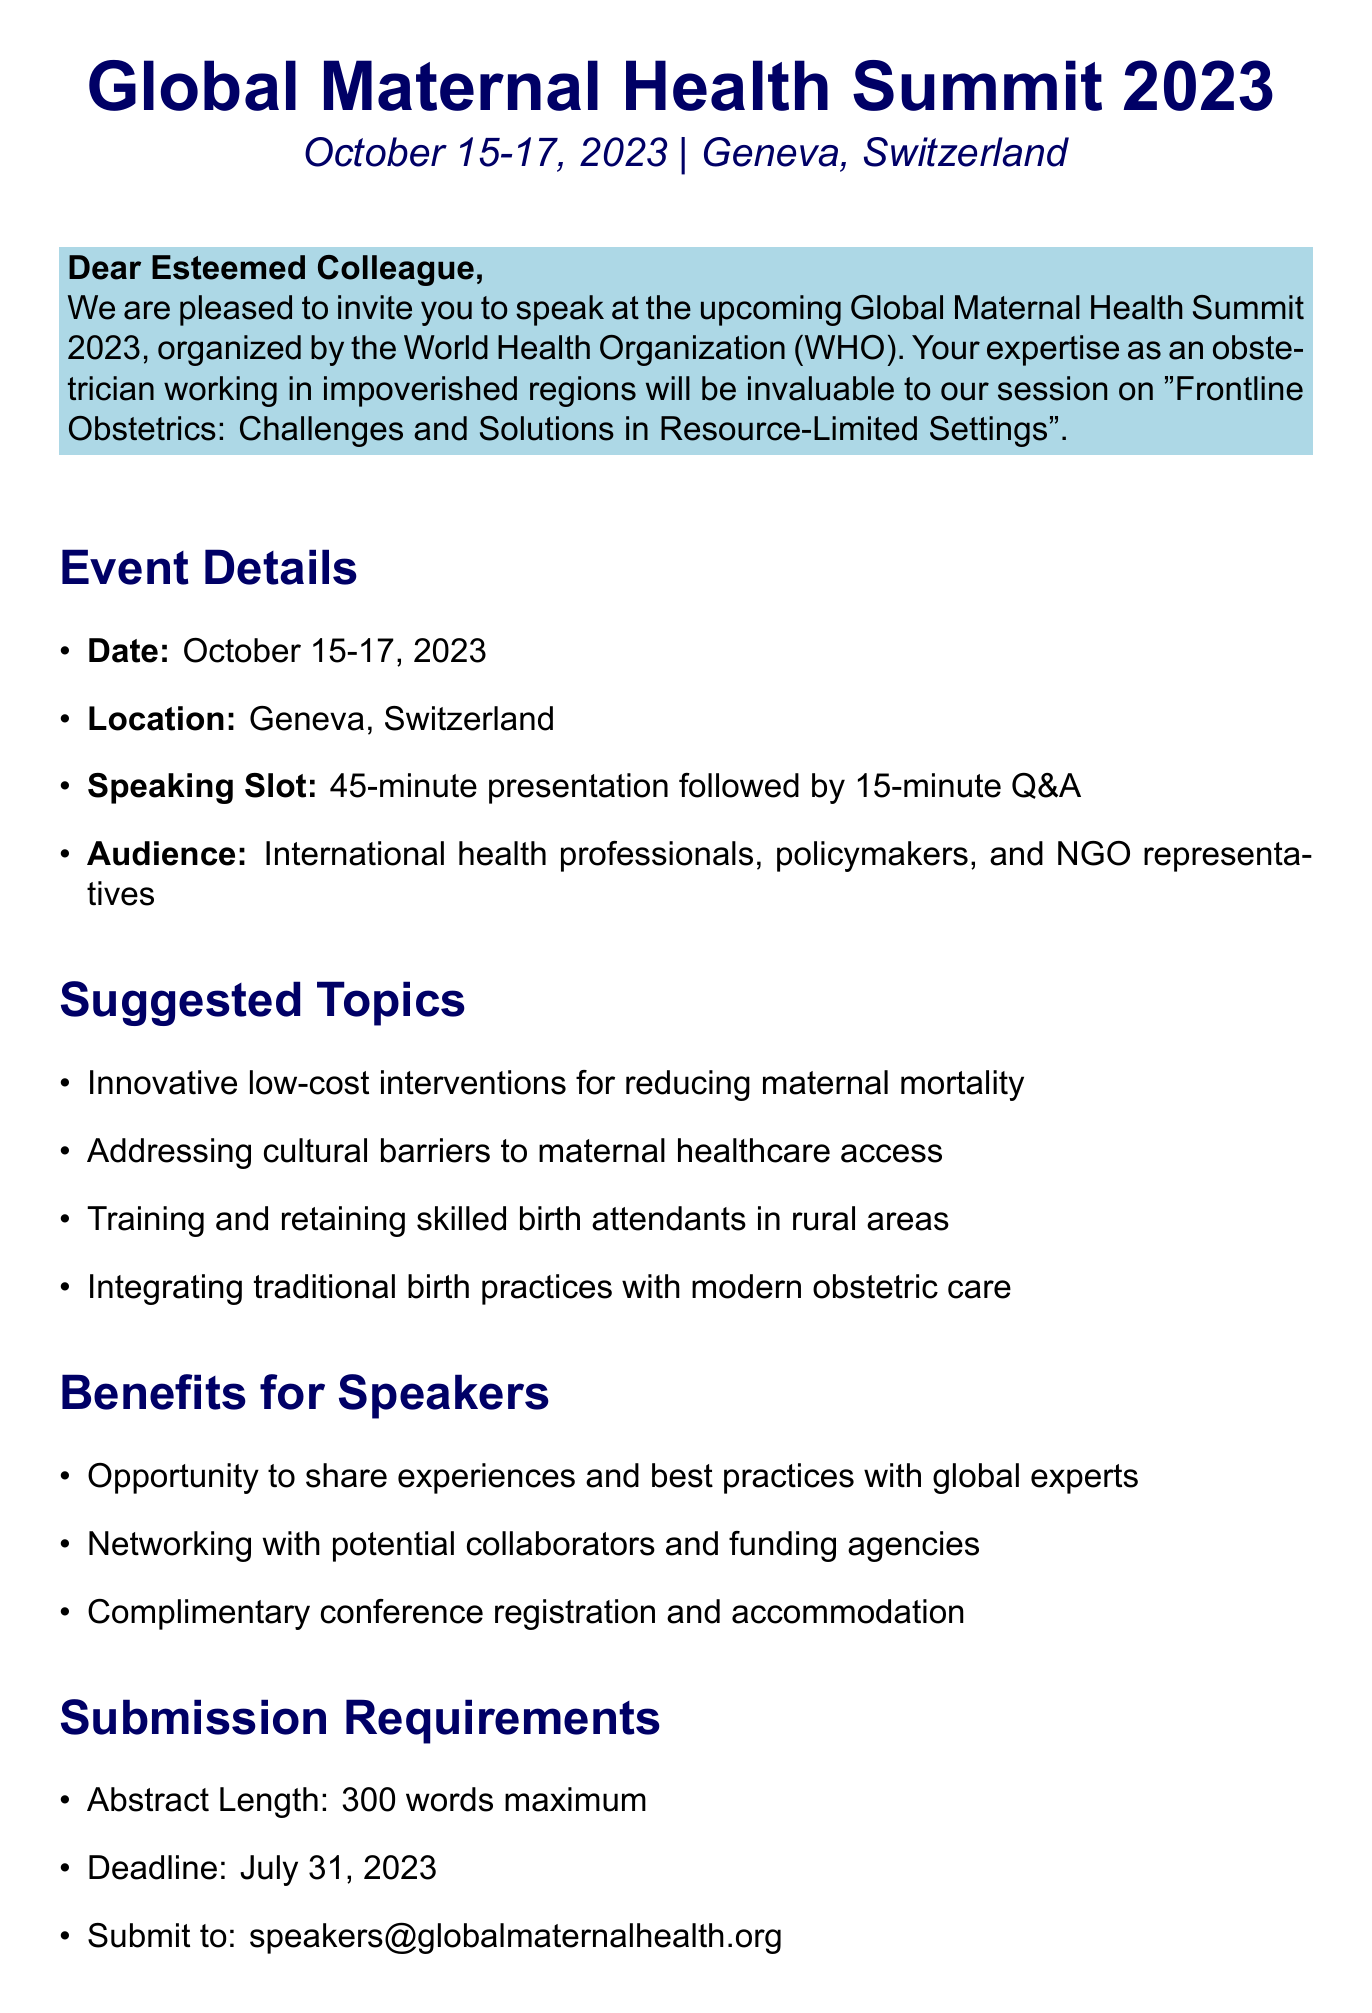what is the name of the conference? The name of the conference is mentioned in the event details of the document.
Answer: Global Maternal Health Summit 2023 what are the conference dates? The conference dates are found in the event details section of the document.
Answer: October 15-17, 2023 where is the conference held? The location of the conference is provided in the event details.
Answer: Geneva, Switzerland who is the organizer of the conference? The organizer is specifically named in the event details.
Answer: World Health Organization (WHO) what is the suggested length of the abstract? The required abstract length can be found in the submission requirements section.
Answer: 300 words maximum what is the deadline for abstract submission? The deadline for submission is detailed in the submission requirements section.
Answer: July 31, 2023 what is the title of the speaking session? The title of the session is stated in the invitation context section.
Answer: Frontline Obstetrics: Challenges and Solutions in Resource-Limited Settings who should the abstracts be submitted to? The submission email is included in the submission requirements section.
Answer: speakers@globalmaternalhealth.org what benefits do speakers receive? The benefits for speakers are listed in the benefits for speakers section.
Answer: Complimentary conference registration and accommodation how long is the speaking slot? The speaking slot duration is provided in the invitation context of the document.
Answer: 45-minute presentation followed by 15-minute Q&A 